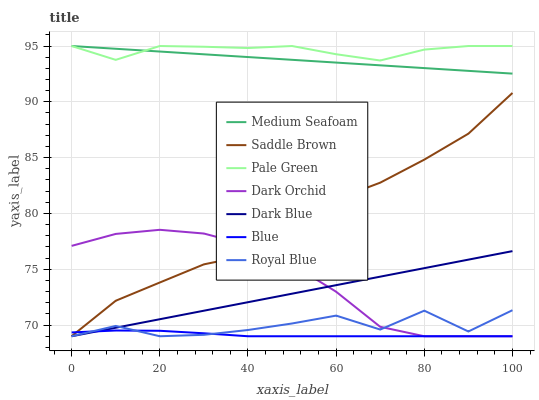Does Blue have the minimum area under the curve?
Answer yes or no. Yes. Does Pale Green have the maximum area under the curve?
Answer yes or no. Yes. Does Royal Blue have the minimum area under the curve?
Answer yes or no. No. Does Royal Blue have the maximum area under the curve?
Answer yes or no. No. Is Dark Blue the smoothest?
Answer yes or no. Yes. Is Royal Blue the roughest?
Answer yes or no. Yes. Is Dark Orchid the smoothest?
Answer yes or no. No. Is Dark Orchid the roughest?
Answer yes or no. No. Does Blue have the lowest value?
Answer yes or no. Yes. Does Saddle Brown have the lowest value?
Answer yes or no. No. Does Medium Seafoam have the highest value?
Answer yes or no. Yes. Does Royal Blue have the highest value?
Answer yes or no. No. Is Royal Blue less than Saddle Brown?
Answer yes or no. Yes. Is Medium Seafoam greater than Royal Blue?
Answer yes or no. Yes. Does Blue intersect Dark Orchid?
Answer yes or no. Yes. Is Blue less than Dark Orchid?
Answer yes or no. No. Is Blue greater than Dark Orchid?
Answer yes or no. No. Does Royal Blue intersect Saddle Brown?
Answer yes or no. No. 